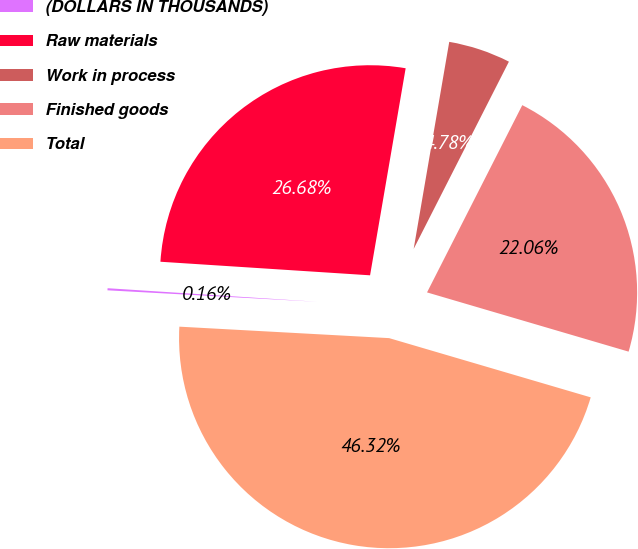Convert chart. <chart><loc_0><loc_0><loc_500><loc_500><pie_chart><fcel>(DOLLARS IN THOUSANDS)<fcel>Raw materials<fcel>Work in process<fcel>Finished goods<fcel>Total<nl><fcel>0.16%<fcel>26.68%<fcel>4.78%<fcel>22.06%<fcel>46.32%<nl></chart> 